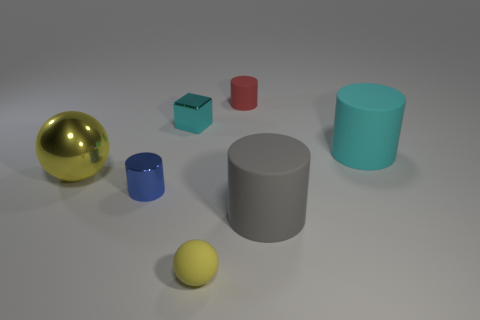Subtract 1 cylinders. How many cylinders are left? 3 Add 1 big green rubber cylinders. How many objects exist? 8 Subtract all balls. How many objects are left? 5 Add 4 large red cubes. How many large red cubes exist? 4 Subtract 0 purple spheres. How many objects are left? 7 Subtract all tiny yellow rubber spheres. Subtract all small red objects. How many objects are left? 5 Add 2 tiny balls. How many tiny balls are left? 3 